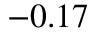Convert formula to latex. <formula><loc_0><loc_0><loc_500><loc_500>- 0 . 1 7</formula> 